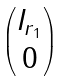Convert formula to latex. <formula><loc_0><loc_0><loc_500><loc_500>\begin{pmatrix} I _ { r _ { 1 } } \\ 0 \end{pmatrix}</formula> 